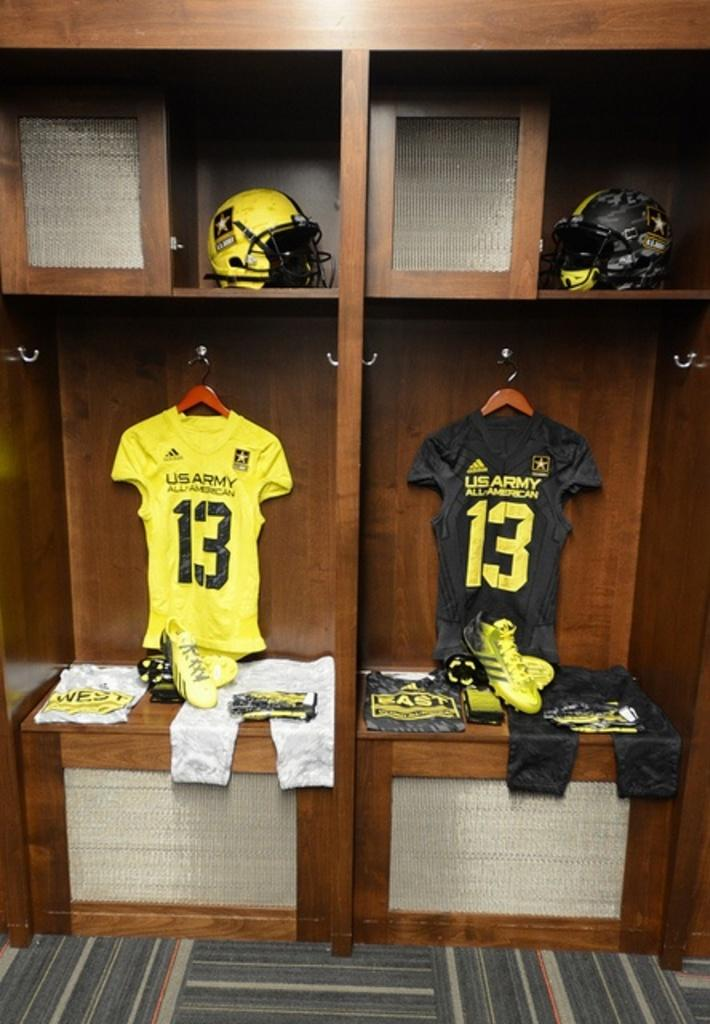<image>
Offer a succinct explanation of the picture presented. A dressing room with two football outfits, one yellow, one black, with US Army All American on the front of the jerseys. 